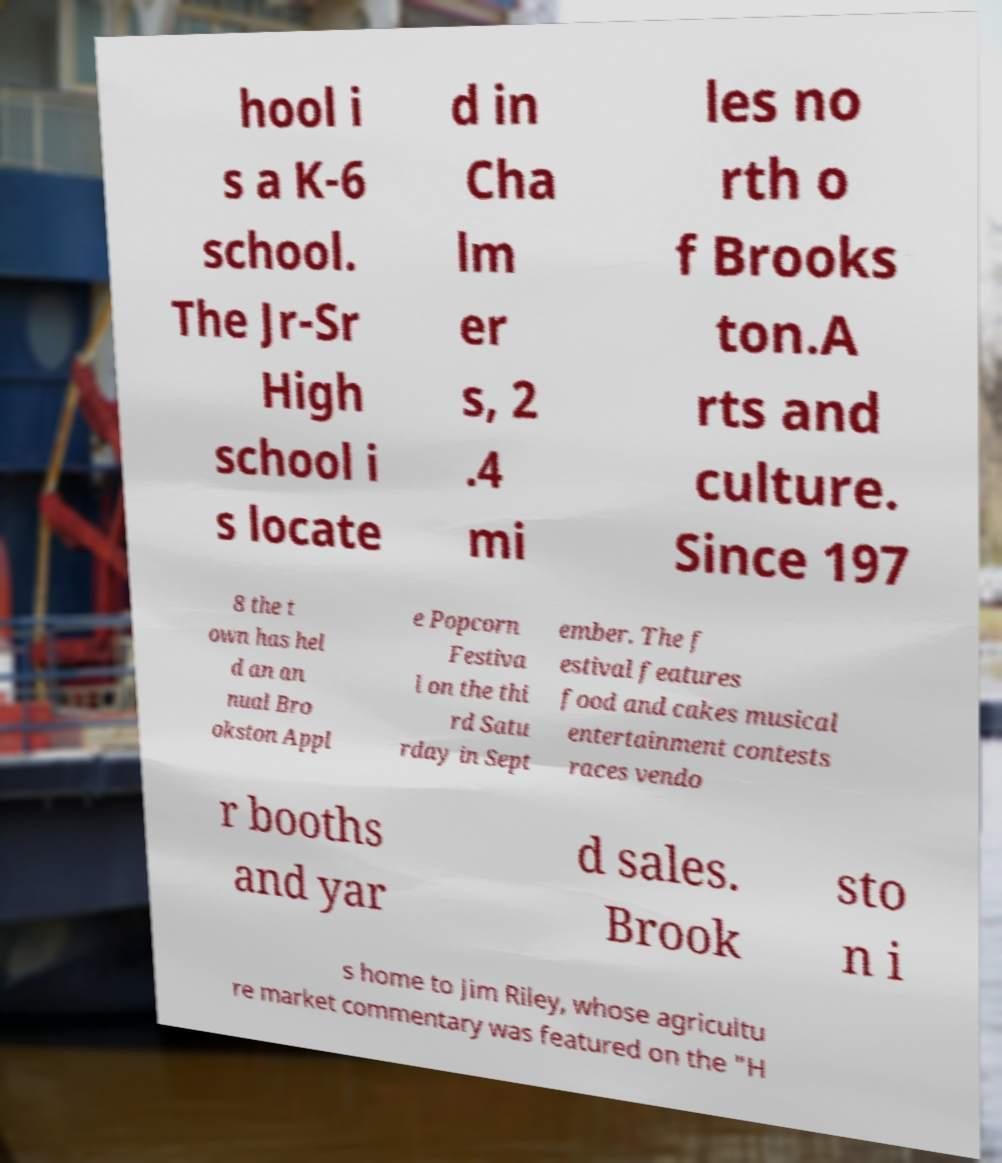Please read and relay the text visible in this image. What does it say? hool i s a K-6 school. The Jr-Sr High school i s locate d in Cha lm er s, 2 .4 mi les no rth o f Brooks ton.A rts and culture. Since 197 8 the t own has hel d an an nual Bro okston Appl e Popcorn Festiva l on the thi rd Satu rday in Sept ember. The f estival features food and cakes musical entertainment contests races vendo r booths and yar d sales. Brook sto n i s home to Jim Riley, whose agricultu re market commentary was featured on the "H 